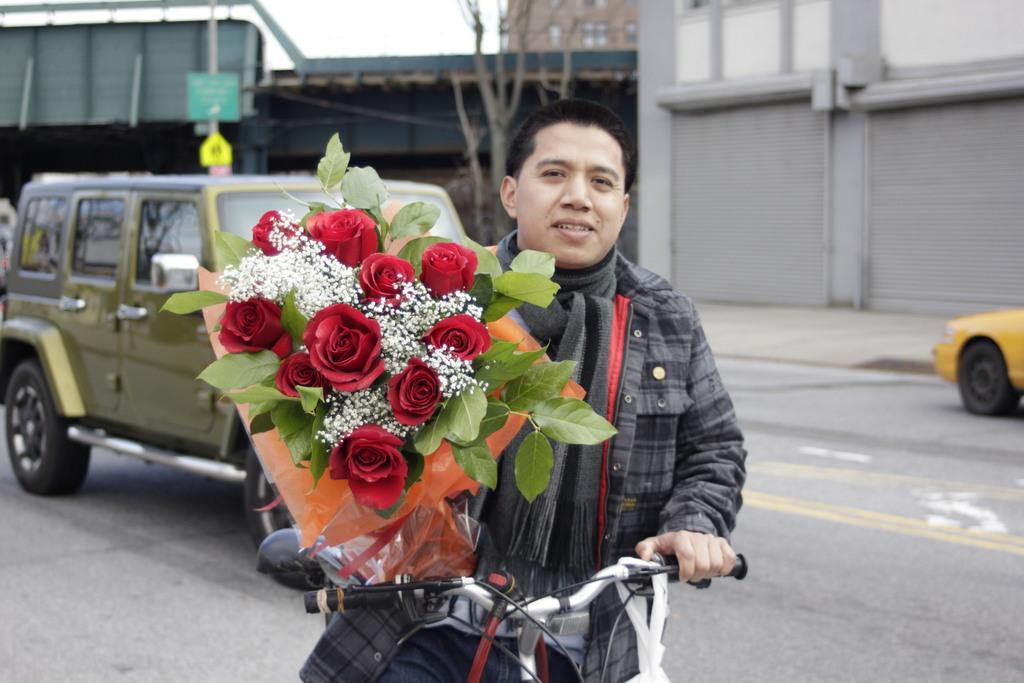What is the main subject of the image? There is a person in the image. What is the person holding in the image? The person is holding a bicycle and a flower bouquet. What can be seen in the background of the image? There are vehicles, buildings, and boards in the background of the image. What type of vegetation is present in the image? There is a tree in the image. What is visible at the top of the image? The sky is visible at the top of the image. What type of vein is visible on the person's face in the image? There is no visible vein on the person's face in the image. What does the person say to the expert in the image? There is no expert or conversation present in the image. 